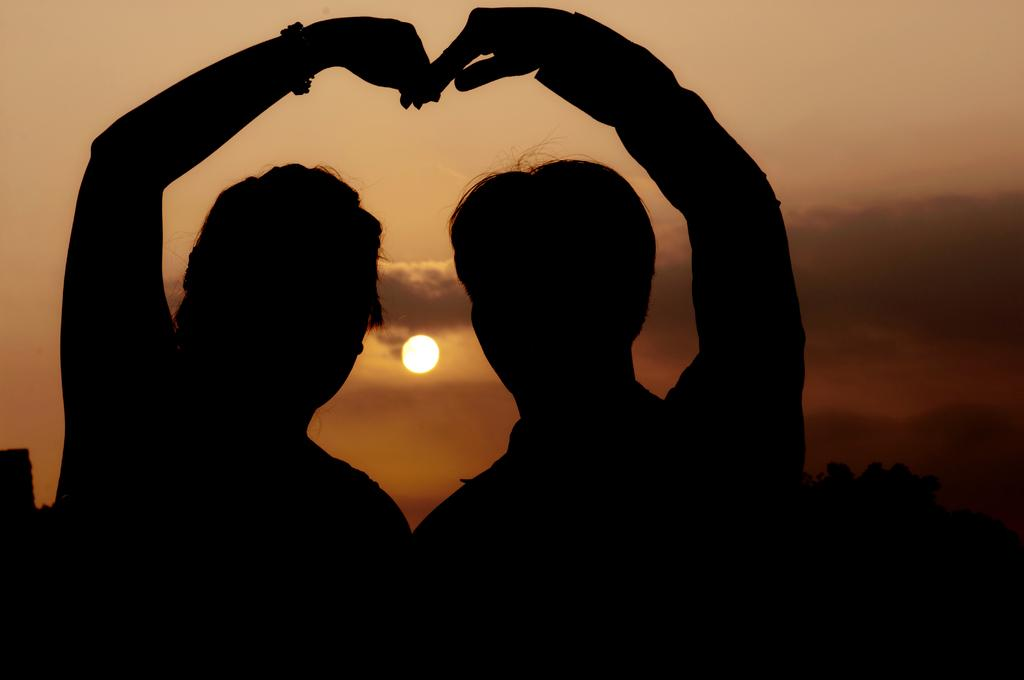Who is present in the image? There is a couple in the image. What are the couple doing in the image? The couple is making a heart symbol with their hands. What is the weather like in the image? The sun is visible in the sky, and there are clouds present. What is the cub's opinion on the print in the image? There is no cub or print present in the image, so it is not possible to determine the cub's opinion. 